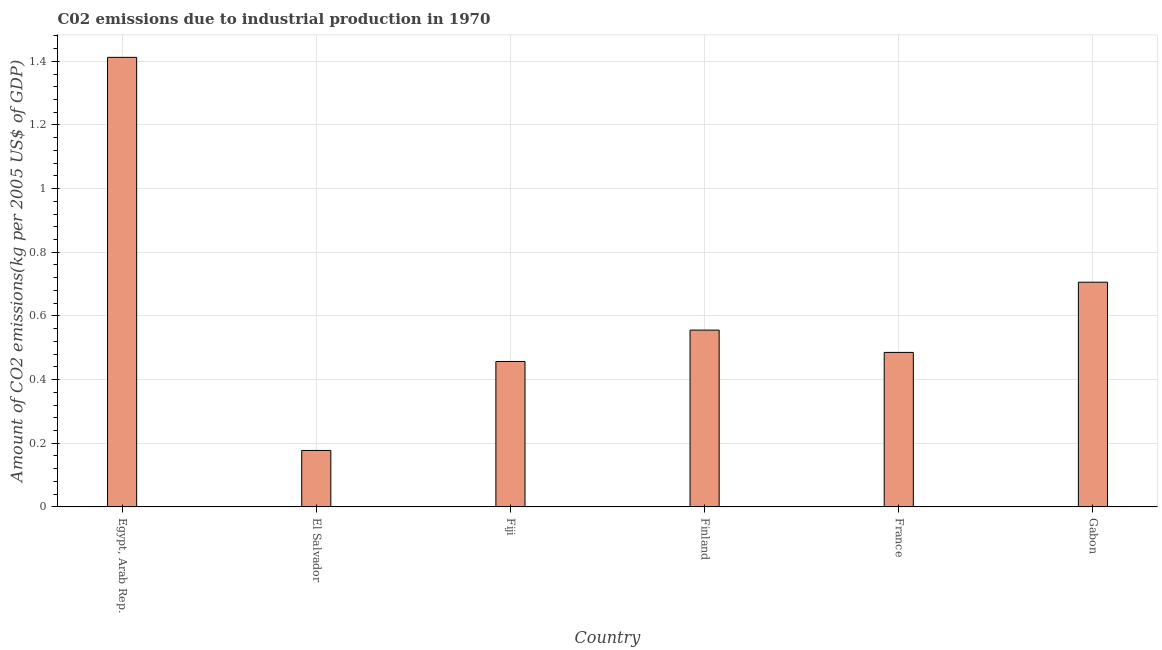What is the title of the graph?
Make the answer very short. C02 emissions due to industrial production in 1970. What is the label or title of the X-axis?
Your answer should be compact. Country. What is the label or title of the Y-axis?
Provide a short and direct response. Amount of CO2 emissions(kg per 2005 US$ of GDP). What is the amount of co2 emissions in France?
Your answer should be compact. 0.49. Across all countries, what is the maximum amount of co2 emissions?
Offer a very short reply. 1.41. Across all countries, what is the minimum amount of co2 emissions?
Provide a succinct answer. 0.18. In which country was the amount of co2 emissions maximum?
Your answer should be very brief. Egypt, Arab Rep. In which country was the amount of co2 emissions minimum?
Offer a very short reply. El Salvador. What is the sum of the amount of co2 emissions?
Ensure brevity in your answer.  3.79. What is the difference between the amount of co2 emissions in Fiji and France?
Your response must be concise. -0.03. What is the average amount of co2 emissions per country?
Keep it short and to the point. 0.63. What is the median amount of co2 emissions?
Your answer should be very brief. 0.52. In how many countries, is the amount of co2 emissions greater than 1.04 kg per 2005 US$ of GDP?
Ensure brevity in your answer.  1. What is the ratio of the amount of co2 emissions in Egypt, Arab Rep. to that in El Salvador?
Ensure brevity in your answer.  7.96. Is the amount of co2 emissions in El Salvador less than that in Finland?
Ensure brevity in your answer.  Yes. What is the difference between the highest and the second highest amount of co2 emissions?
Give a very brief answer. 0.71. Is the sum of the amount of co2 emissions in Fiji and Finland greater than the maximum amount of co2 emissions across all countries?
Ensure brevity in your answer.  No. What is the difference between the highest and the lowest amount of co2 emissions?
Keep it short and to the point. 1.23. How many bars are there?
Keep it short and to the point. 6. What is the difference between two consecutive major ticks on the Y-axis?
Offer a terse response. 0.2. Are the values on the major ticks of Y-axis written in scientific E-notation?
Your response must be concise. No. What is the Amount of CO2 emissions(kg per 2005 US$ of GDP) in Egypt, Arab Rep.?
Keep it short and to the point. 1.41. What is the Amount of CO2 emissions(kg per 2005 US$ of GDP) of El Salvador?
Give a very brief answer. 0.18. What is the Amount of CO2 emissions(kg per 2005 US$ of GDP) of Fiji?
Your answer should be very brief. 0.46. What is the Amount of CO2 emissions(kg per 2005 US$ of GDP) of Finland?
Offer a very short reply. 0.56. What is the Amount of CO2 emissions(kg per 2005 US$ of GDP) in France?
Give a very brief answer. 0.49. What is the Amount of CO2 emissions(kg per 2005 US$ of GDP) in Gabon?
Your response must be concise. 0.71. What is the difference between the Amount of CO2 emissions(kg per 2005 US$ of GDP) in Egypt, Arab Rep. and El Salvador?
Make the answer very short. 1.23. What is the difference between the Amount of CO2 emissions(kg per 2005 US$ of GDP) in Egypt, Arab Rep. and Fiji?
Provide a succinct answer. 0.96. What is the difference between the Amount of CO2 emissions(kg per 2005 US$ of GDP) in Egypt, Arab Rep. and Finland?
Offer a very short reply. 0.86. What is the difference between the Amount of CO2 emissions(kg per 2005 US$ of GDP) in Egypt, Arab Rep. and France?
Give a very brief answer. 0.93. What is the difference between the Amount of CO2 emissions(kg per 2005 US$ of GDP) in Egypt, Arab Rep. and Gabon?
Your response must be concise. 0.71. What is the difference between the Amount of CO2 emissions(kg per 2005 US$ of GDP) in El Salvador and Fiji?
Ensure brevity in your answer.  -0.28. What is the difference between the Amount of CO2 emissions(kg per 2005 US$ of GDP) in El Salvador and Finland?
Give a very brief answer. -0.38. What is the difference between the Amount of CO2 emissions(kg per 2005 US$ of GDP) in El Salvador and France?
Provide a succinct answer. -0.31. What is the difference between the Amount of CO2 emissions(kg per 2005 US$ of GDP) in El Salvador and Gabon?
Your answer should be compact. -0.53. What is the difference between the Amount of CO2 emissions(kg per 2005 US$ of GDP) in Fiji and Finland?
Your answer should be compact. -0.1. What is the difference between the Amount of CO2 emissions(kg per 2005 US$ of GDP) in Fiji and France?
Give a very brief answer. -0.03. What is the difference between the Amount of CO2 emissions(kg per 2005 US$ of GDP) in Fiji and Gabon?
Ensure brevity in your answer.  -0.25. What is the difference between the Amount of CO2 emissions(kg per 2005 US$ of GDP) in Finland and France?
Provide a short and direct response. 0.07. What is the difference between the Amount of CO2 emissions(kg per 2005 US$ of GDP) in Finland and Gabon?
Make the answer very short. -0.15. What is the difference between the Amount of CO2 emissions(kg per 2005 US$ of GDP) in France and Gabon?
Offer a terse response. -0.22. What is the ratio of the Amount of CO2 emissions(kg per 2005 US$ of GDP) in Egypt, Arab Rep. to that in El Salvador?
Keep it short and to the point. 7.96. What is the ratio of the Amount of CO2 emissions(kg per 2005 US$ of GDP) in Egypt, Arab Rep. to that in Fiji?
Keep it short and to the point. 3.09. What is the ratio of the Amount of CO2 emissions(kg per 2005 US$ of GDP) in Egypt, Arab Rep. to that in Finland?
Give a very brief answer. 2.54. What is the ratio of the Amount of CO2 emissions(kg per 2005 US$ of GDP) in Egypt, Arab Rep. to that in France?
Give a very brief answer. 2.91. What is the ratio of the Amount of CO2 emissions(kg per 2005 US$ of GDP) in El Salvador to that in Fiji?
Your answer should be compact. 0.39. What is the ratio of the Amount of CO2 emissions(kg per 2005 US$ of GDP) in El Salvador to that in Finland?
Offer a very short reply. 0.32. What is the ratio of the Amount of CO2 emissions(kg per 2005 US$ of GDP) in El Salvador to that in France?
Your answer should be compact. 0.37. What is the ratio of the Amount of CO2 emissions(kg per 2005 US$ of GDP) in El Salvador to that in Gabon?
Give a very brief answer. 0.25. What is the ratio of the Amount of CO2 emissions(kg per 2005 US$ of GDP) in Fiji to that in Finland?
Provide a short and direct response. 0.82. What is the ratio of the Amount of CO2 emissions(kg per 2005 US$ of GDP) in Fiji to that in France?
Provide a short and direct response. 0.94. What is the ratio of the Amount of CO2 emissions(kg per 2005 US$ of GDP) in Fiji to that in Gabon?
Ensure brevity in your answer.  0.65. What is the ratio of the Amount of CO2 emissions(kg per 2005 US$ of GDP) in Finland to that in France?
Give a very brief answer. 1.14. What is the ratio of the Amount of CO2 emissions(kg per 2005 US$ of GDP) in Finland to that in Gabon?
Your answer should be compact. 0.79. What is the ratio of the Amount of CO2 emissions(kg per 2005 US$ of GDP) in France to that in Gabon?
Offer a very short reply. 0.69. 